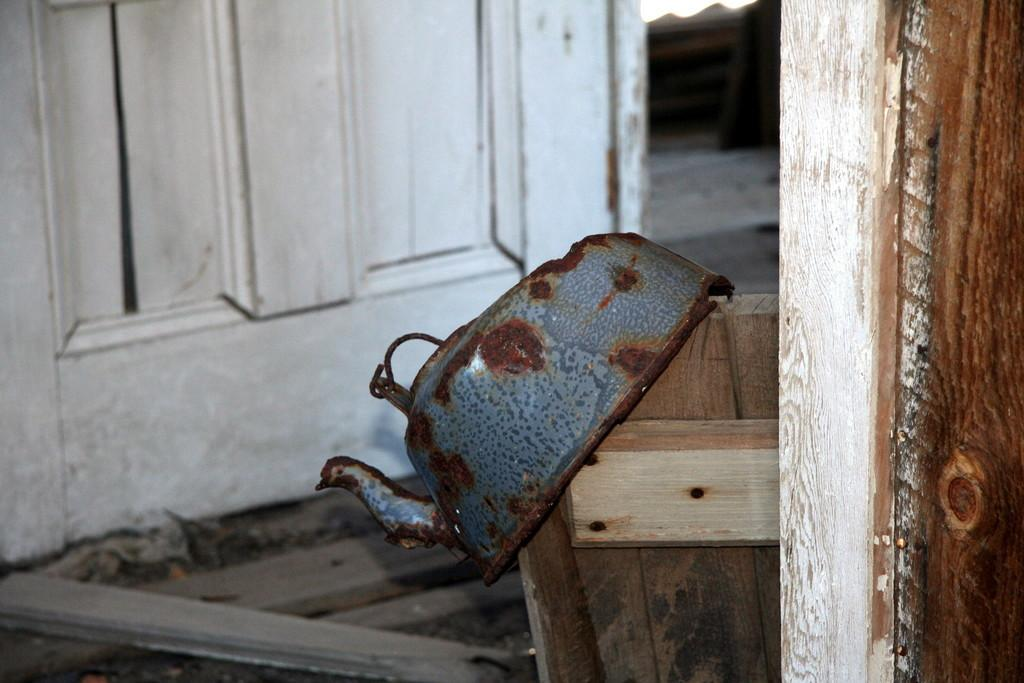What is the main object in the image? There is a door in the image. What material is present on the right side of the image? There is wood on the right side of the image. What object can be seen in the middle of the image? There is a kettle in the middle of the image. What type of behavior is the bat exhibiting in the image? There is no bat present in the image. 